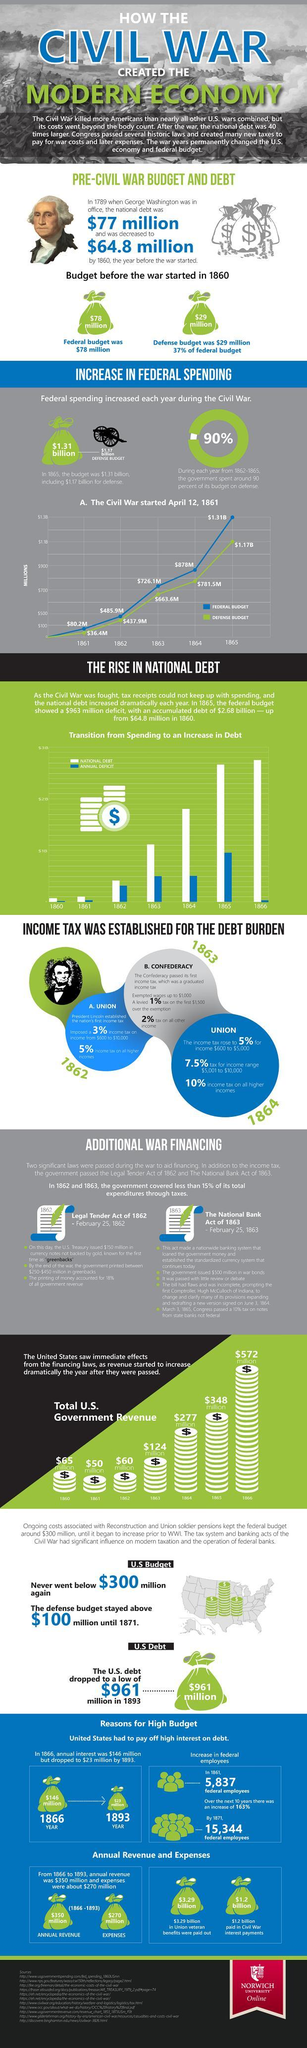When did the American civil war end?
Answer the question with a short phrase. 1865 What was the federal budget of the U.S. in 1864? $878M What was the defense budget of the U.S. in 1862? $437.9M Who was the U.S. president in 1789? George Washington Which year the Defense budget reached the peak value during the civil war? 1865 When did the U.S. president Lincoln established the nation's first income tax? 1862 